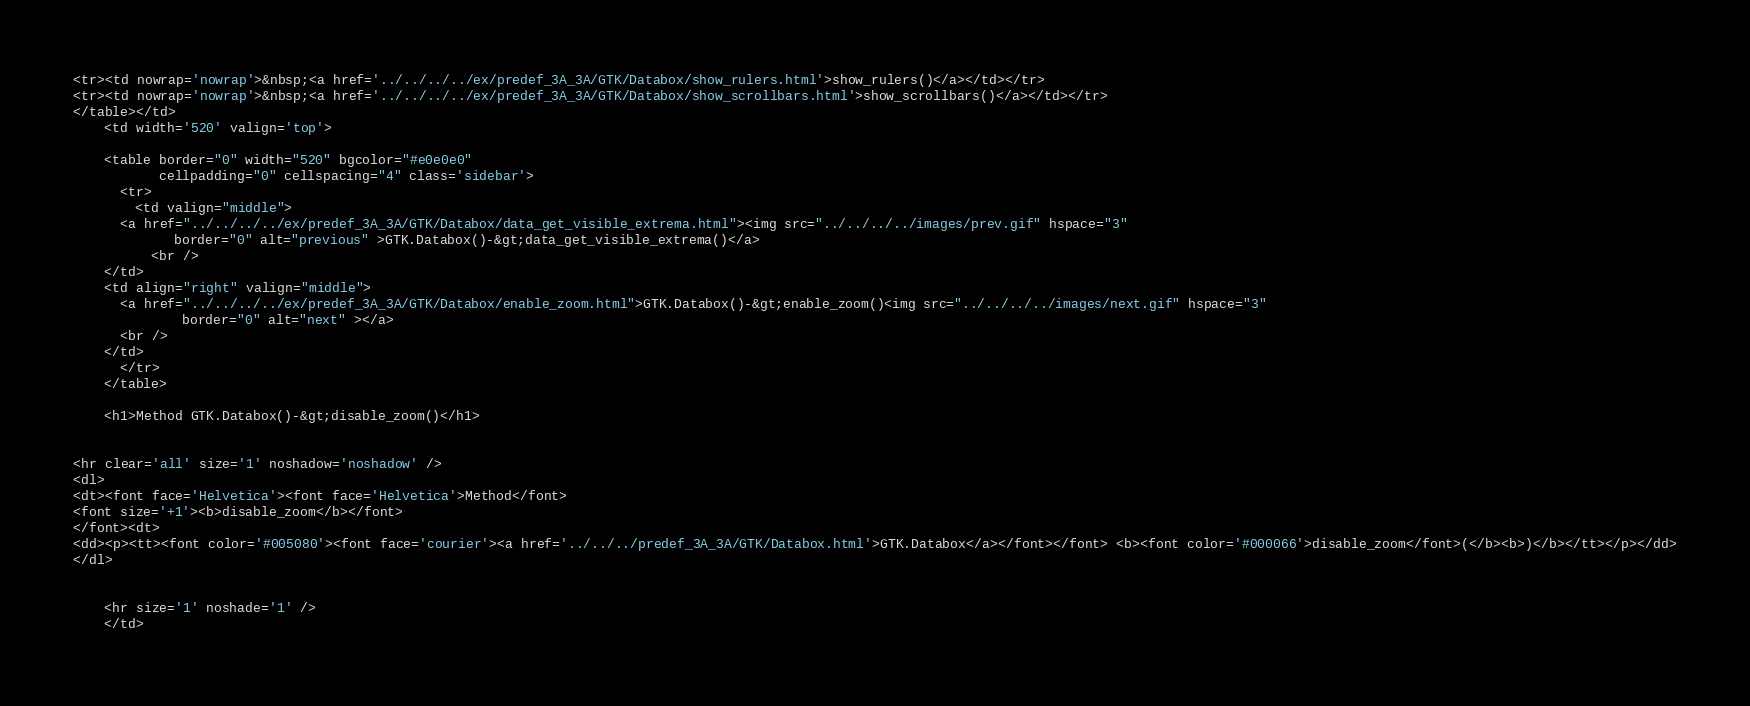<code> <loc_0><loc_0><loc_500><loc_500><_HTML_><tr><td nowrap='nowrap'>&nbsp;<a href='../../../../ex/predef_3A_3A/GTK/Databox/show_rulers.html'>show_rulers()</a></td></tr>
<tr><td nowrap='nowrap'>&nbsp;<a href='../../../../ex/predef_3A_3A/GTK/Databox/show_scrollbars.html'>show_scrollbars()</a></td></tr>
</table></td>
    <td width='520' valign='top'>

    <table border="0" width="520" bgcolor="#e0e0e0"
           cellpadding="0" cellspacing="4" class='sidebar'>
      <tr>
        <td valign="middle">
	  <a href="../../../../ex/predef_3A_3A/GTK/Databox/data_get_visible_extrema.html"><img src="../../../../images/prev.gif" hspace="3"
	         border="0" alt="previous" >GTK.Databox()-&gt;data_get_visible_extrema()</a>
          <br />
	</td>
	<td align="right" valign="middle">
	  <a href="../../../../ex/predef_3A_3A/GTK/Databox/enable_zoom.html">GTK.Databox()-&gt;enable_zoom()<img src="../../../../images/next.gif" hspace="3"
	          border="0" alt="next" ></a>
	  <br />
	</td>
      </tr>
    </table>

    <h1>Method GTK.Databox()-&gt;disable_zoom()</h1>
    

<hr clear='all' size='1' noshadow='noshadow' />
<dl>
<dt><font face='Helvetica'><font face='Helvetica'>Method</font>
<font size='+1'><b>disable_zoom</b></font>
</font><dt>
<dd><p><tt><font color='#005080'><font face='courier'><a href='../../../predef_3A_3A/GTK/Databox.html'>GTK.Databox</a></font></font> <b><font color='#000066'>disable_zoom</font>(</b><b>)</b></tt></p></dd>
</dl>


    <hr size='1' noshade='1' />
    </td></code> 